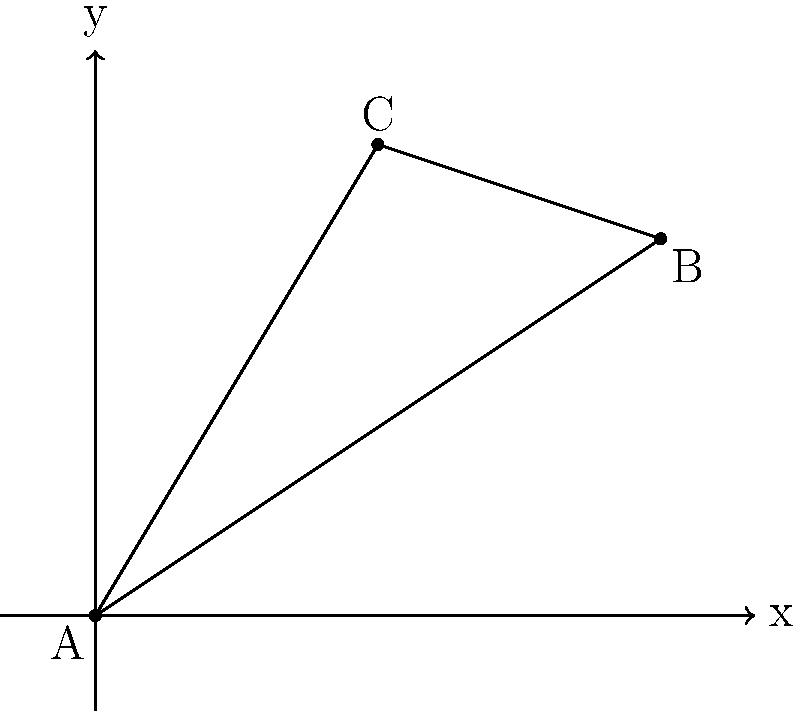In a comic book layout, a speech bubble's edge is represented by the line passing through points A(0,0) and B(6,4). To ensure proper alignment with the character's mouth, the edge needs to pass through a third point C(3,5). Determine the equation of the line that represents this edge of the speech bubble. To find the equation of the line, we'll follow these steps:

1) First, let's check if point C lies on the line passing through A and B:

   Slope of AB: $m_{AB} = \frac{4-0}{6-0} = \frac{2}{3}$

   If C is on this line, it should satisfy the equation:
   $y - y_1 = m(x - x_1)$, where $(x_1, y_1)$ is point A(0,0)

   $5 - 0 = \frac{2}{3}(3 - 0)$
   $5 \neq 2$

   So, C is not on the line AB.

2) We need to find a new line that passes through all three points. We can use the point-slope form of a line equation:

   $y - y_1 = m(x - x_1)$

3) To find the slope, we can use any two points. Let's use A and C:

   $m = \frac{y_C - y_A}{x_C - x_A} = \frac{5 - 0}{3 - 0} = \frac{5}{3}$

4) Now we can use point A(0,0) and this slope in the point-slope form:

   $y - 0 = \frac{5}{3}(x - 0)$

5) Simplify to get the equation in slope-intercept form:

   $y = \frac{5}{3}x$

This equation represents the edge of the speech bubble that passes through all three points, ensuring proper alignment with the character's mouth in the comic book layout.
Answer: $y = \frac{5}{3}x$ 